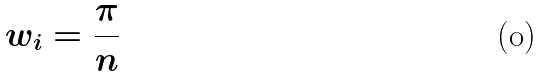<formula> <loc_0><loc_0><loc_500><loc_500>w _ { i } = \frac { \pi } { n }</formula> 